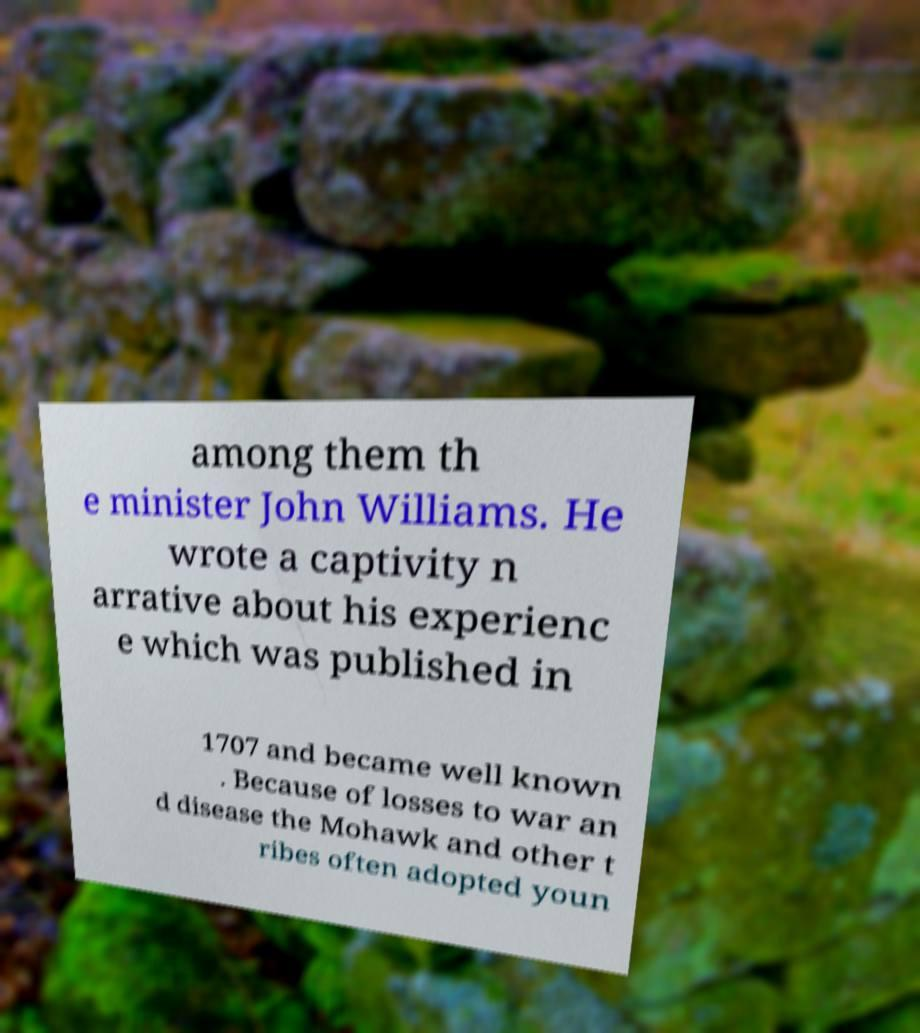What messages or text are displayed in this image? I need them in a readable, typed format. among them th e minister John Williams. He wrote a captivity n arrative about his experienc e which was published in 1707 and became well known . Because of losses to war an d disease the Mohawk and other t ribes often adopted youn 